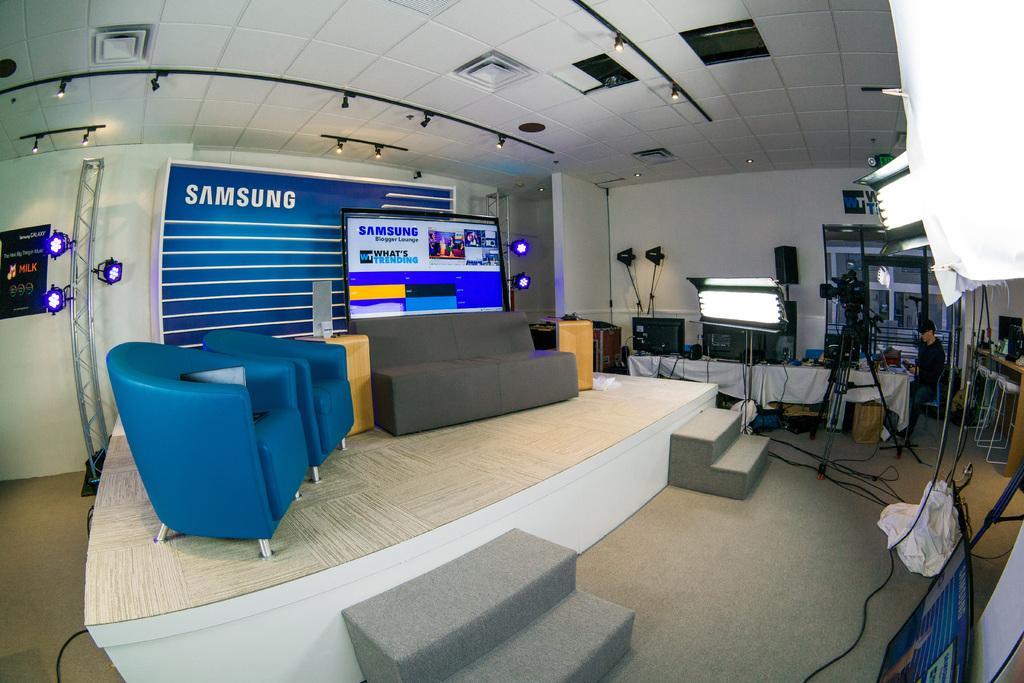Could you give a brief overview of what you see in this image? This picture is an inside view of a room. In the center of the image we can see a stage. On stage we can see a couch, chairs, tables. In the middle of the image we can see a table. On the table we can see the clothes, speakers, screen and some other objects. In the background of the image we can see the wall, screen, lights, boards, a person is sitting, tables and other objects. At the top of the image we can see the roof and lights. At the bottom of the image we can see the floor, cloth, board and wires. On the right side of the image we can see a camera with stand. 